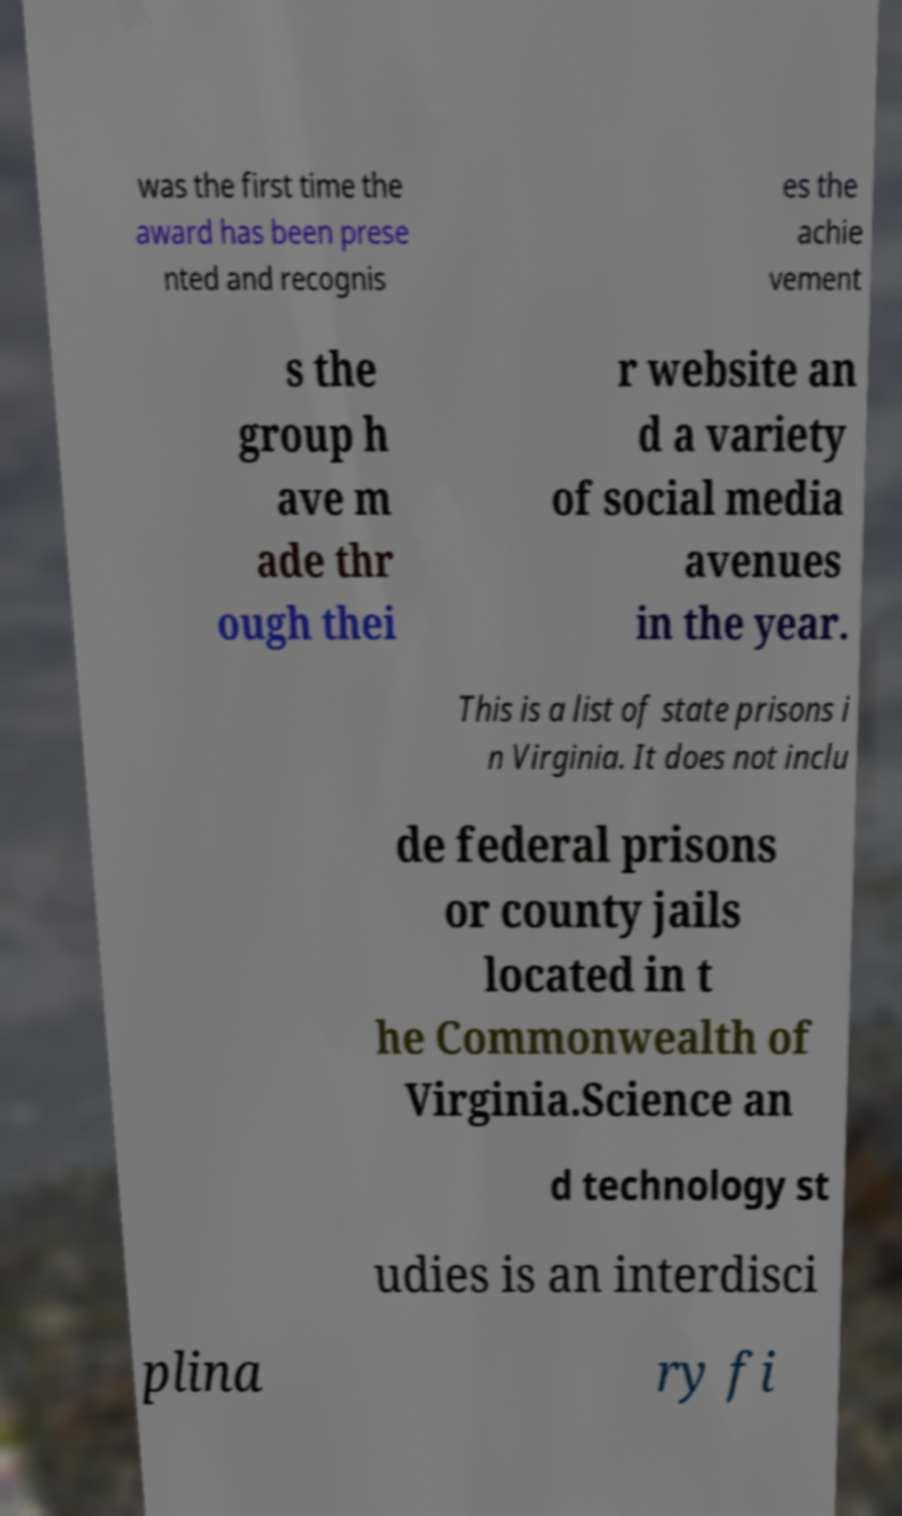Can you accurately transcribe the text from the provided image for me? was the first time the award has been prese nted and recognis es the achie vement s the group h ave m ade thr ough thei r website an d a variety of social media avenues in the year. This is a list of state prisons i n Virginia. It does not inclu de federal prisons or county jails located in t he Commonwealth of Virginia.Science an d technology st udies is an interdisci plina ry fi 